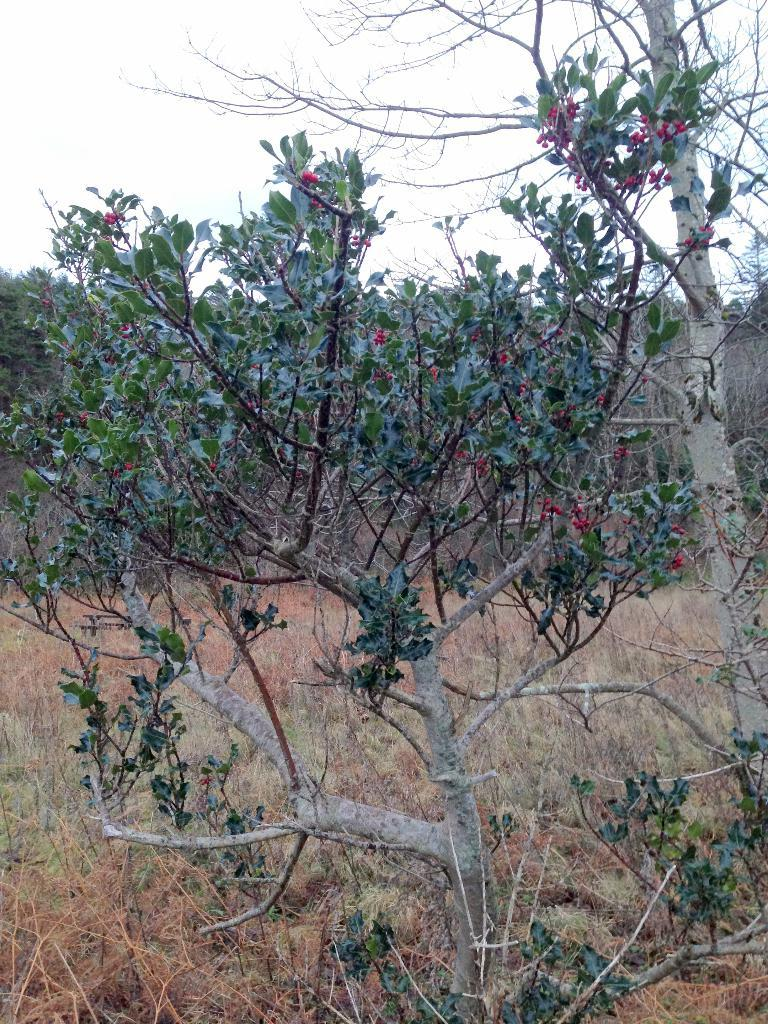What type of vegetation can be seen in the image? There are trees in the image. What else can be seen on the ground in the image? There is grass in the image. What is visible in the background of the image? The sky is visible in the background of the image. Is there any quicksand visible in the image? No, there is no quicksand present in the image. How does the grip of the trees affect the cable in the image? There is no cable present in the image, so the grip of the trees does not affect any cable. 